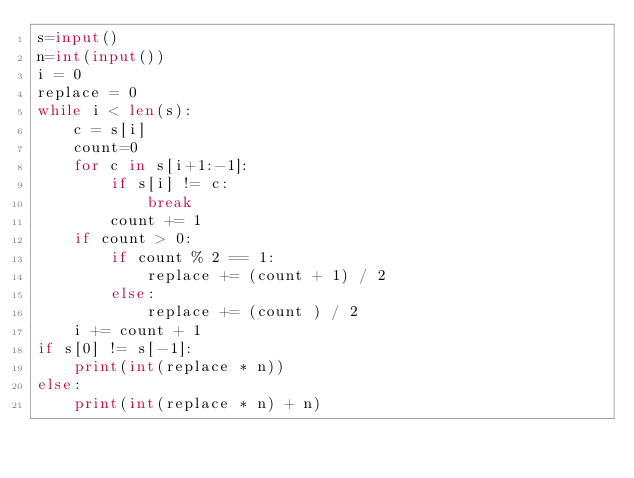<code> <loc_0><loc_0><loc_500><loc_500><_Python_>s=input()
n=int(input())
i = 0
replace = 0
while i < len(s):
    c = s[i]
    count=0
    for c in s[i+1:-1]:
        if s[i] != c:
            break
        count += 1
    if count > 0:
        if count % 2 == 1:
            replace += (count + 1) / 2
        else:
            replace += (count ) / 2
    i += count + 1
if s[0] != s[-1]:
    print(int(replace * n))
else:
    print(int(replace * n) + n)</code> 